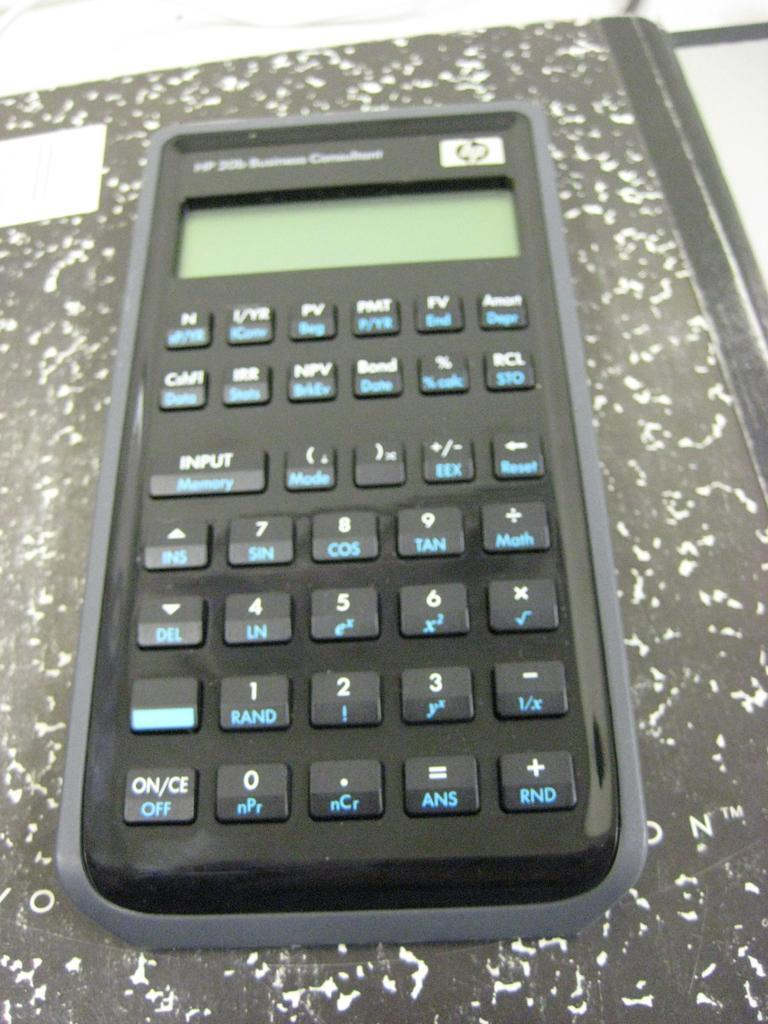<image>
Describe the image concisely. Black HP calculator on top of a black and white notebook. 